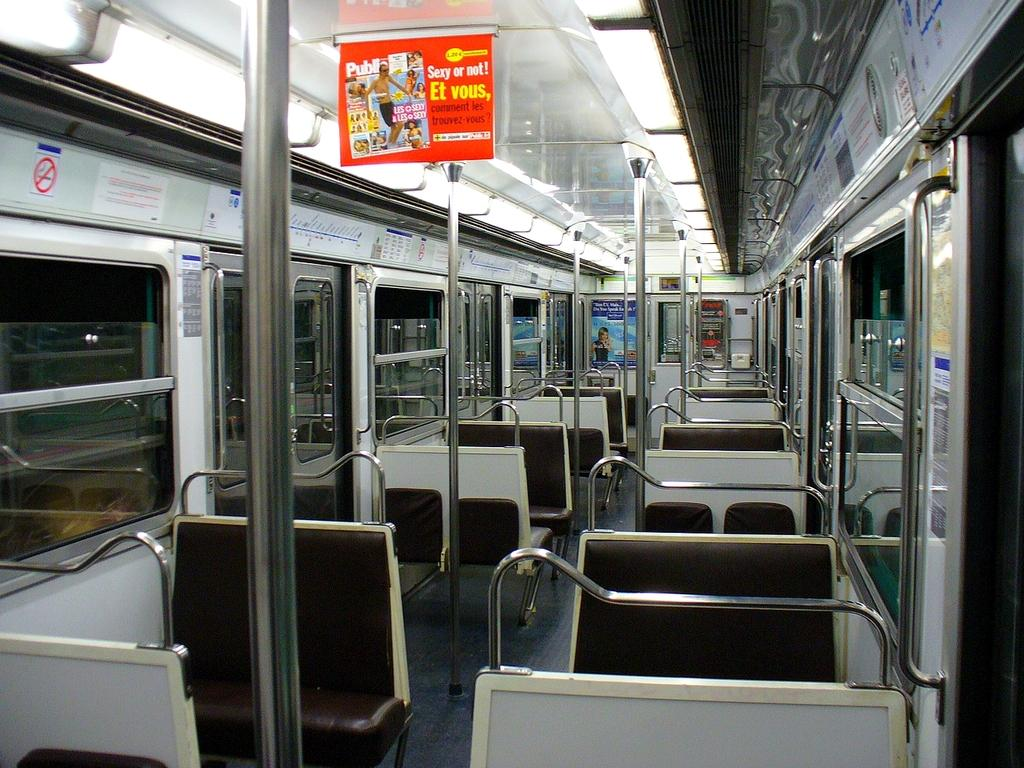<image>
Create a compact narrative representing the image presented. an advertisement above the bus that says sexy or not. 